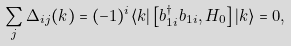Convert formula to latex. <formula><loc_0><loc_0><loc_500><loc_500>\sum _ { j } \Delta _ { i j } ( k ) = ( - 1 ) ^ { i } \langle k | \left [ b ^ { \dagger } _ { 1 i } b _ { 1 i } , H _ { 0 } \right ] | k \rangle = 0 ,</formula> 